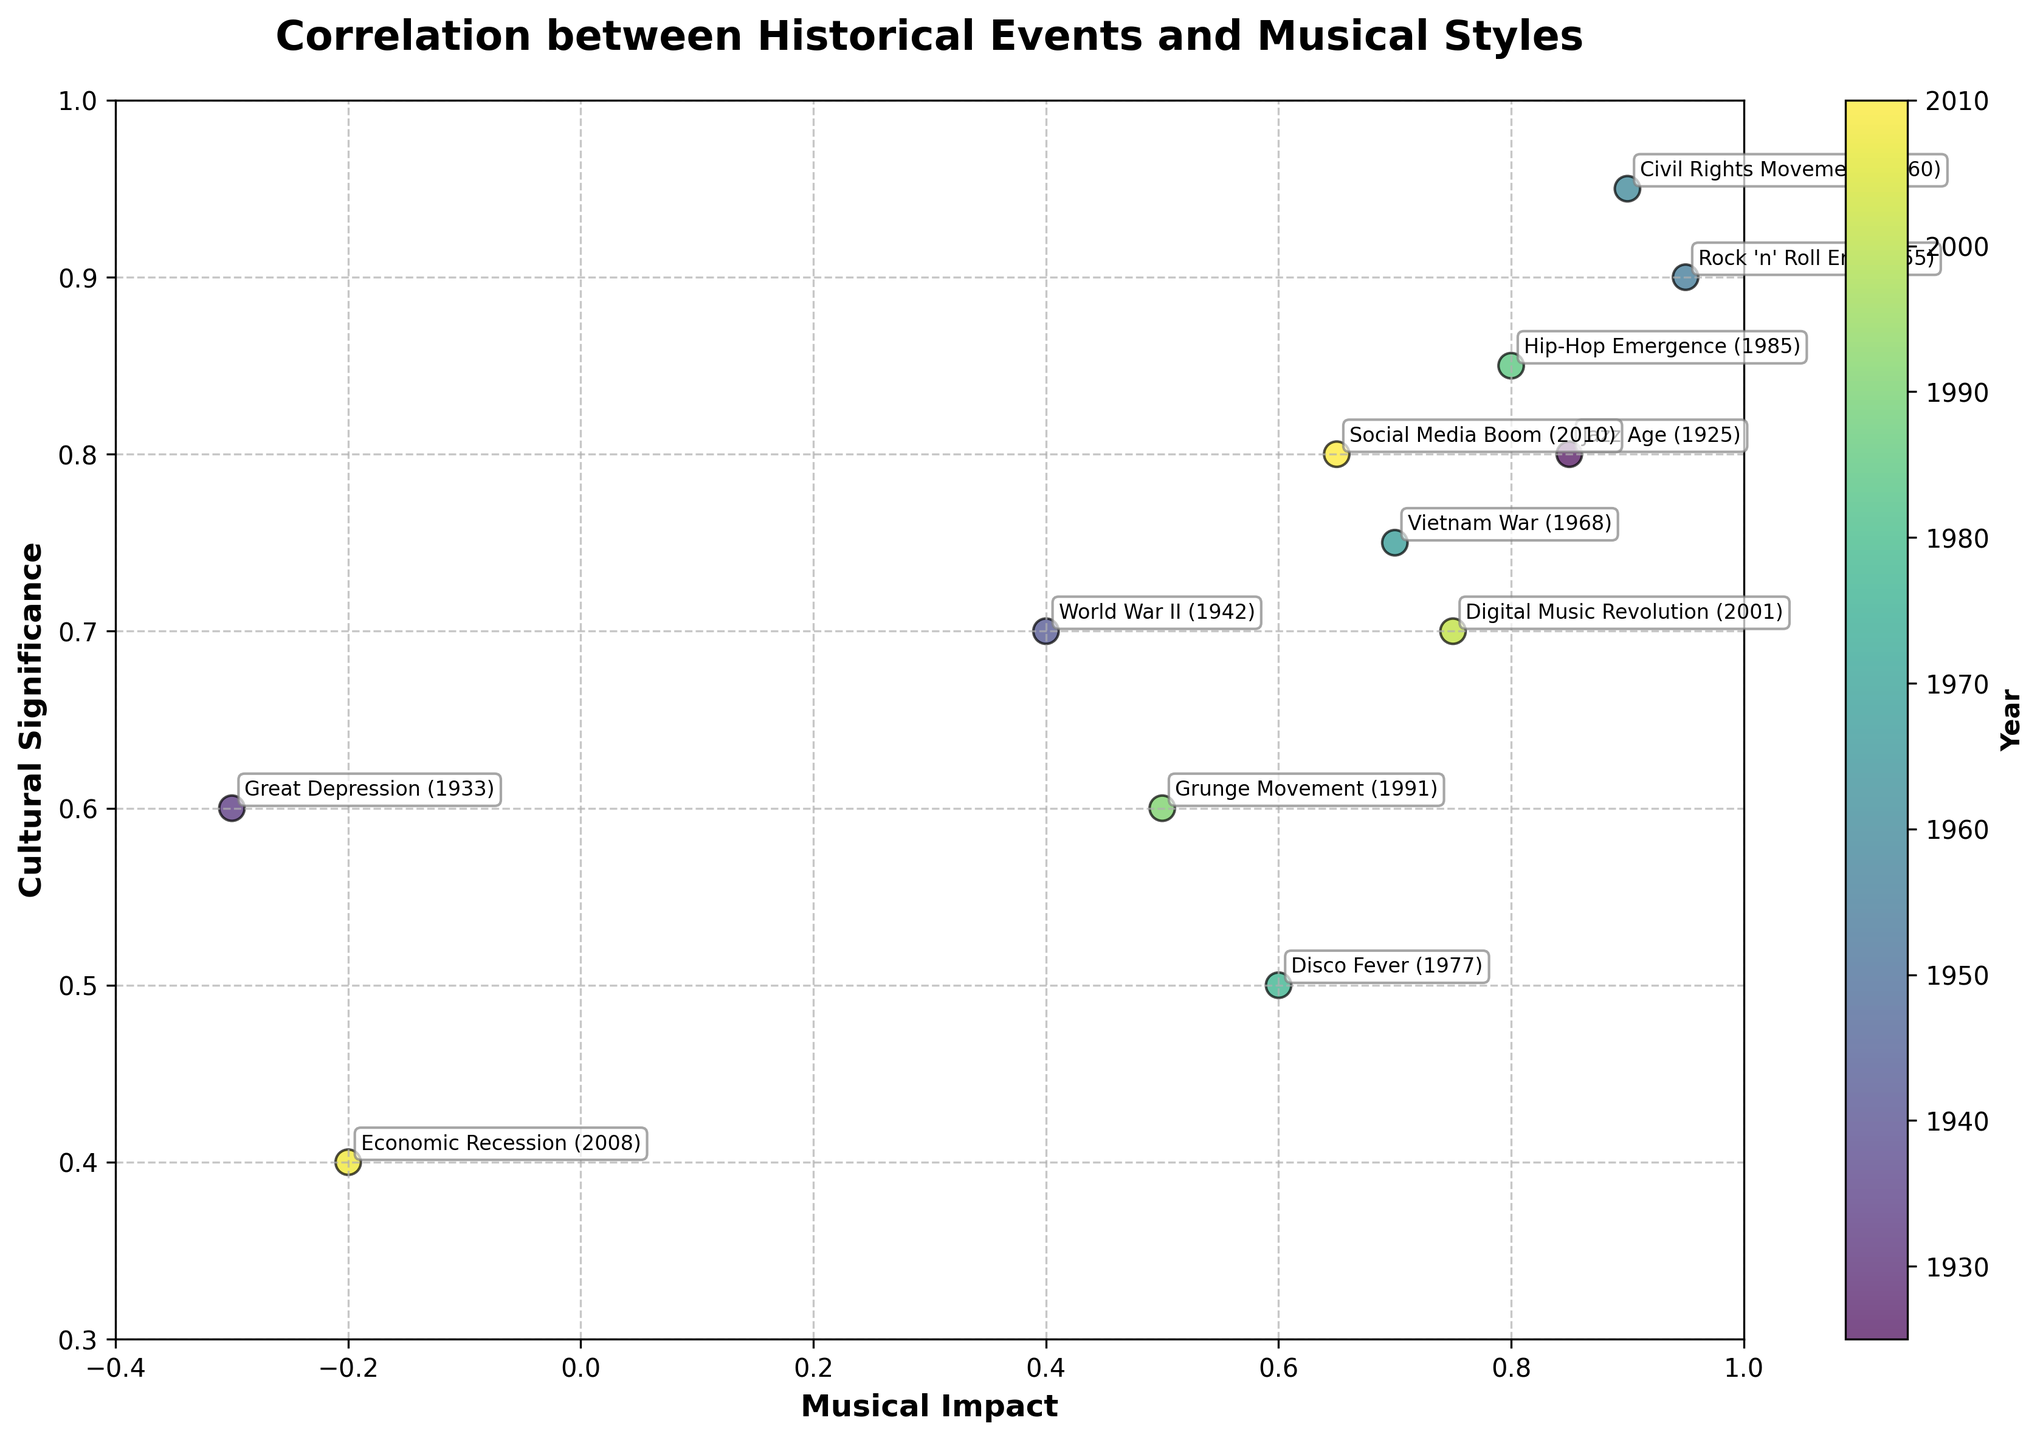How many events are represented in the plot? Count the number of events listed or the number of scatter points on the plot.
Answer: 12 Which historical event has the highest musical impact? Look at the x-axis (Musical Impact) and identify the event with the scatter point farthest to the right.
Answer: Rock 'n' Roll Era What is the title of the plot? Read the title displayed at the top of the plot.
Answer: Correlation between Historical Events and Musical Styles Which event occurred the earliest and what is its cultural significance? Identify the event with the lowest corresponding year and check its cultural significance on the y-axis.
Answer: Jazz Age, 0.8 What is the range of the musical impact values? Identify the minimum and maximum values on the x-axis. The range is from the lowest to the highest value.
Answer: -0.3 to 0.95 What is the average cultural significance of the events before 1970? Identify events before 1970, sum their cultural significance values, then divide by the number of these events.
Answer: (0.95 + 0.8 + 0.6 + 0.7 + 0.9) / 5 = 0.79 Which events have a negative musical impact and what are their years? Find scatter points to the left of zero on the x-axis and identify the corresponding events and years.
Answer: Great Depression (1933), Economic Recession (2008) How did the Vietnam War impact both music and culture compared to the Civil Rights Movement? Compare the Vietnam War's and Civil Rights Movement's positions on the x-axis (Musical Impact) and y-axis (Cultural Significance).
Answer: Lower on both axes Which event from the plot has the highest cultural significance and when did it happen? Look at the y-axis (Cultural Significance) and identify the event with the scatter point highest up, then check its year.
Answer: Civil Rights Movement, 1960 